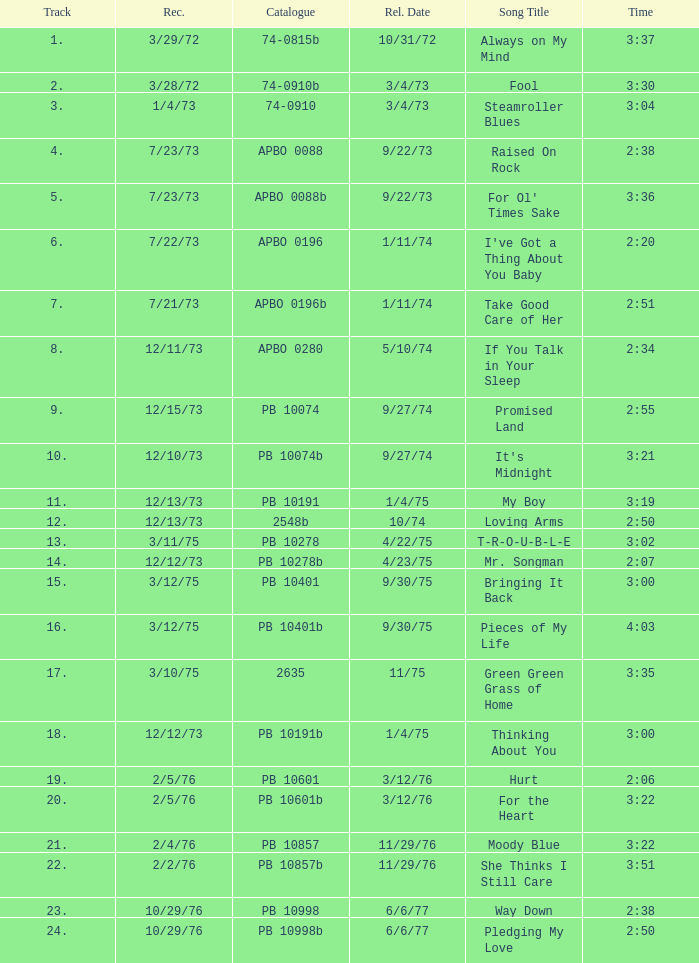Tell me the release date record on 10/29/76 and a time on 2:50 6/6/77. 